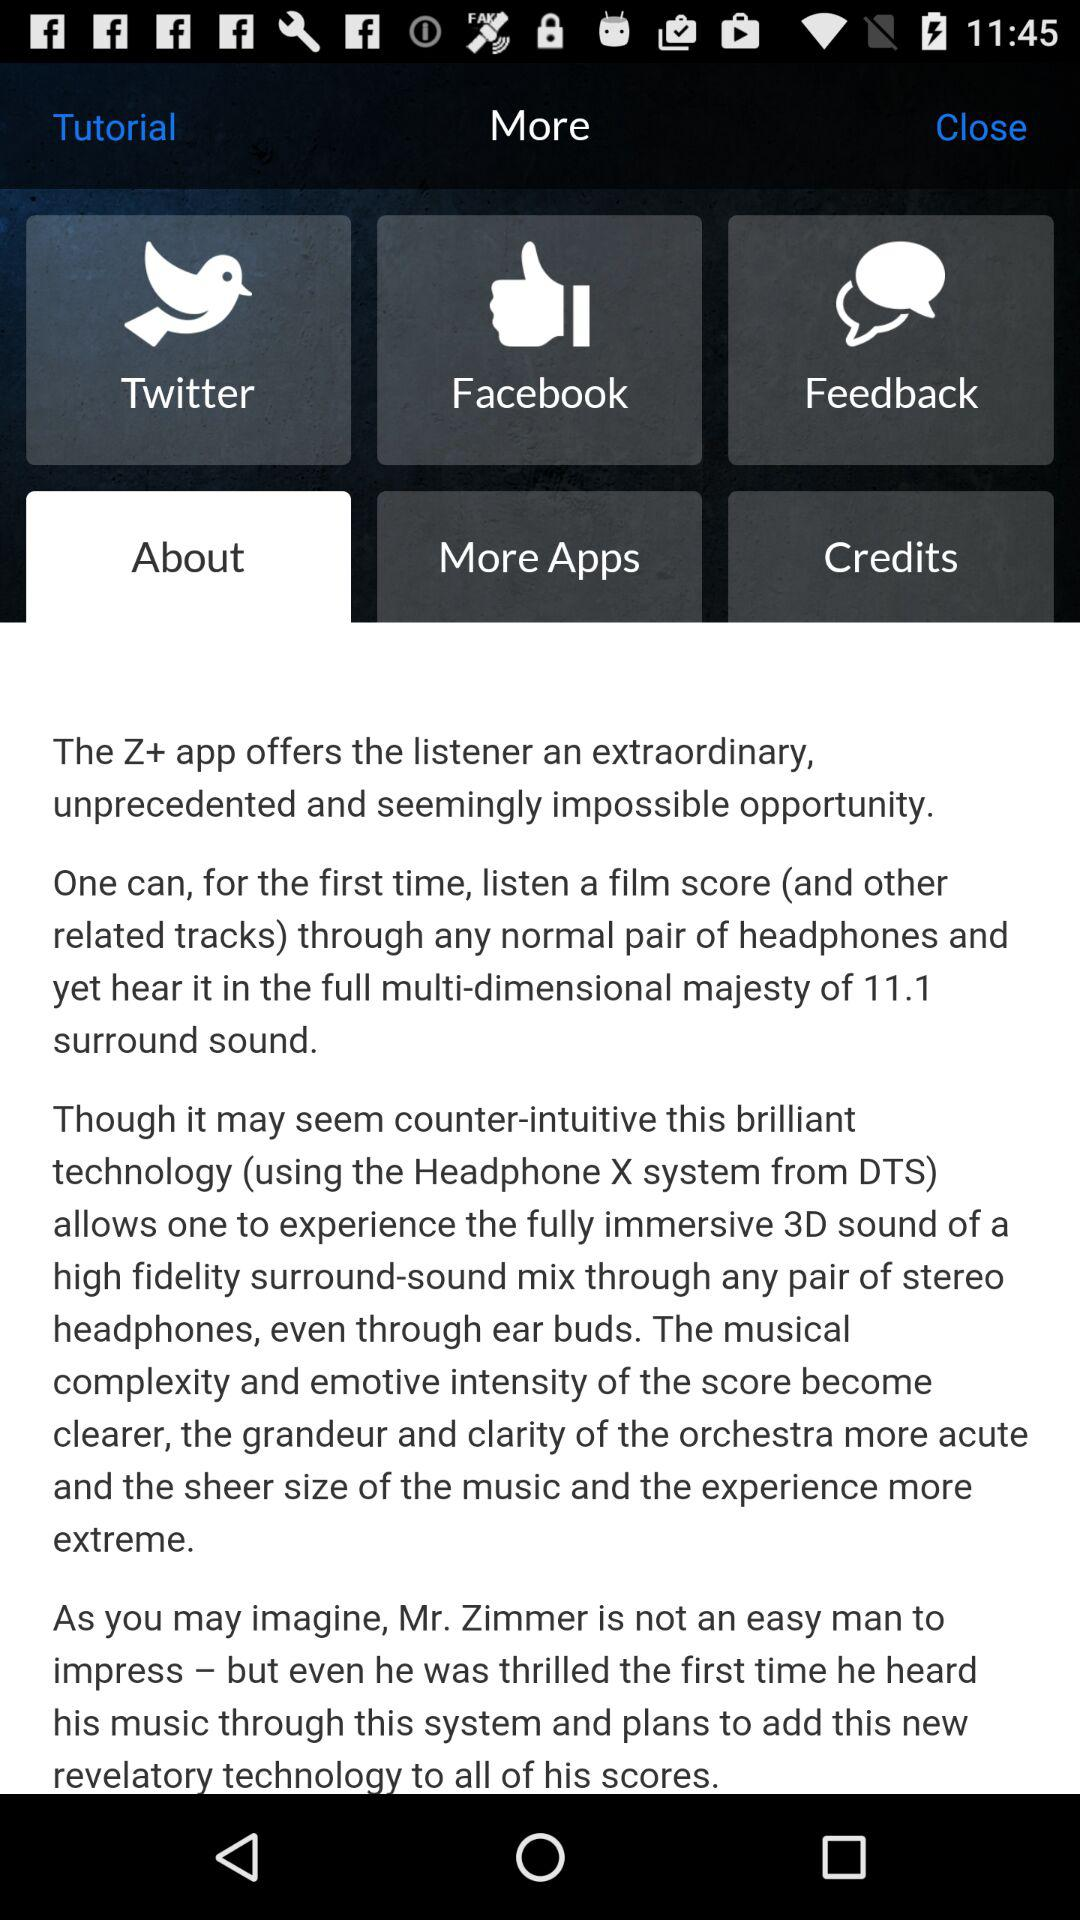Which tab is currently selected? The currently selected tabs are "More" and "About". 